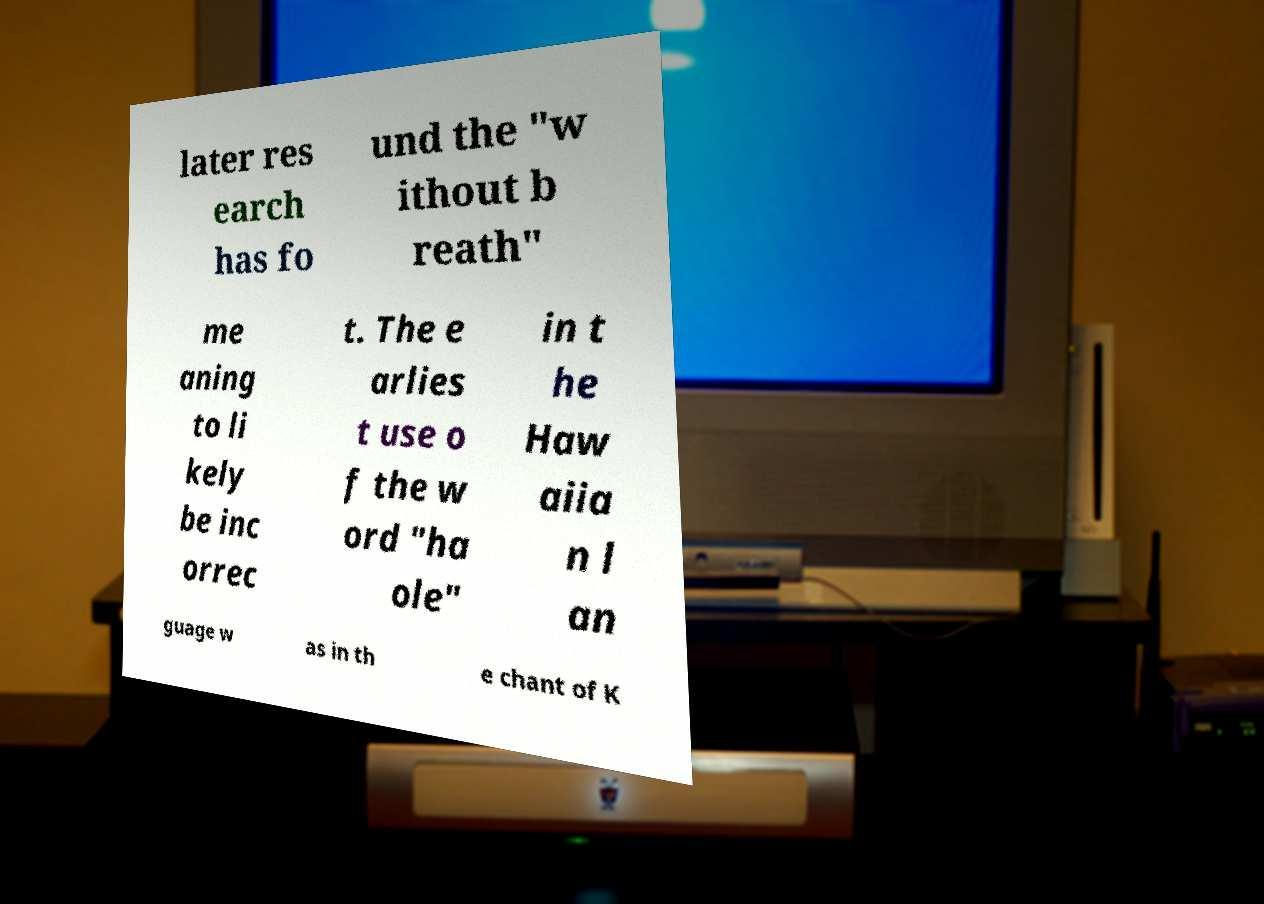I need the written content from this picture converted into text. Can you do that? later res earch has fo und the "w ithout b reath" me aning to li kely be inc orrec t. The e arlies t use o f the w ord "ha ole" in t he Haw aiia n l an guage w as in th e chant of K 